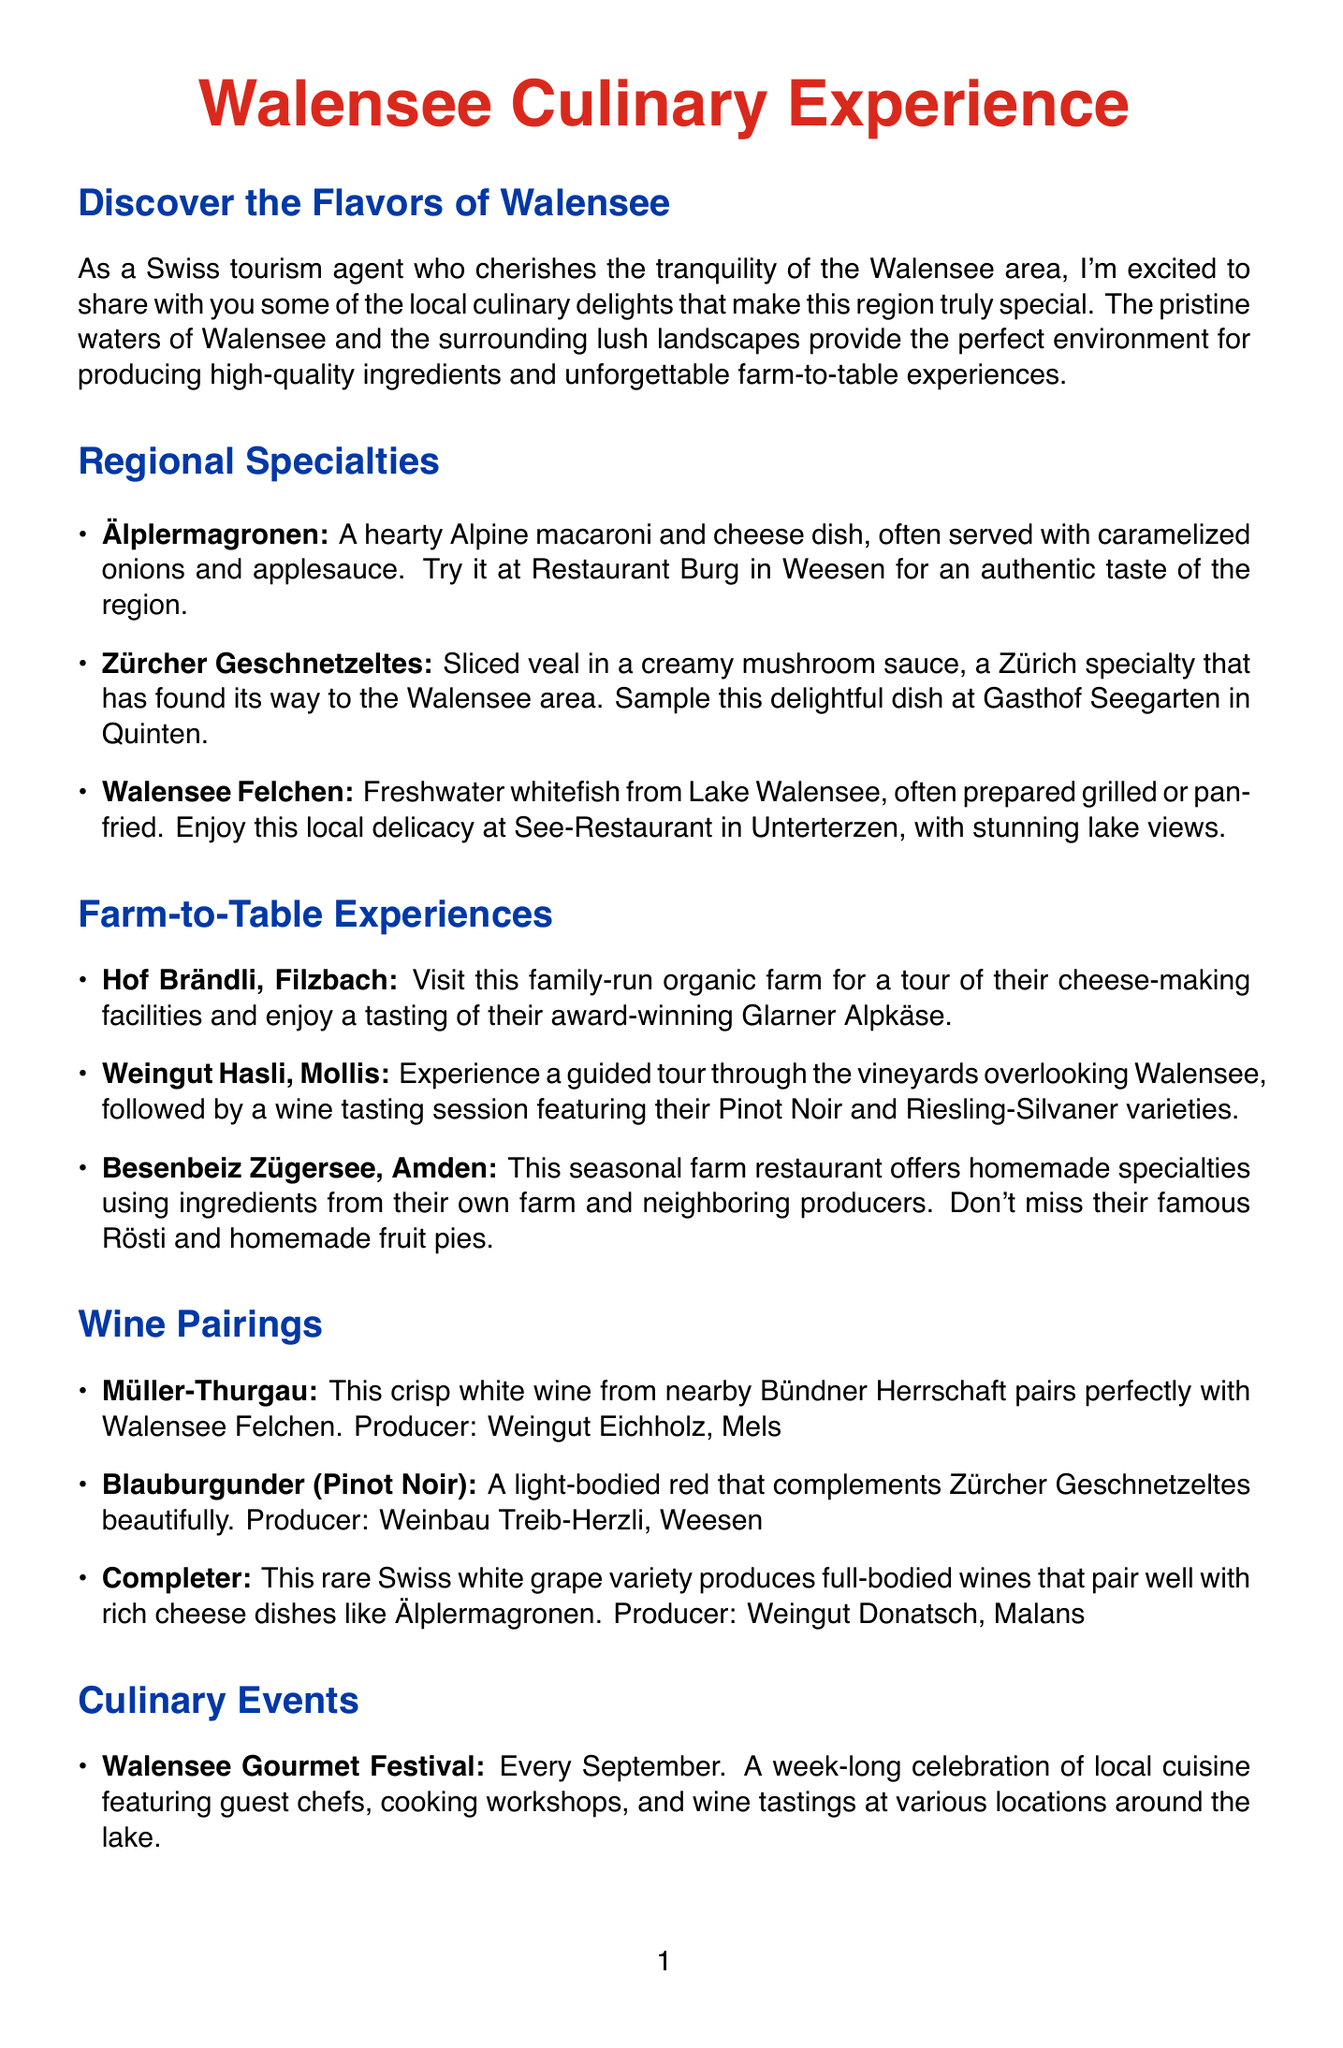What is the first culinary specialty mentioned? The first culinary specialty listed in the document is Älplermagronen.
Answer: Älplermagronen Where is Hof Brändli located? Hof Brändli is located in Filzbach.
Answer: Filzbach Which wine pairs perfectly with Walensee Felchen? The wine that pairs perfectly with Walensee Felchen is Müller-Thurgau.
Answer: Müller-Thurgau What month does the Walensee Gourmet Festival occur? The Walensee Gourmet Festival takes place every September.
Answer: September Which dish complements Zürcher Geschnetzeltes? The dish that complements Zürcher Geschnetzeltes is Blauburgunder (Pinot Noir).
Answer: Blauburgunder (Pinot Noir) What type of cheese is offered at Hof Brändli? Hof Brändli offers Glarner Alpkäse.
Answer: Glarner Alpkäse During which weekend is the Amden Alpkäse Market held? The Amden Alpkäse Market is held on the first weekend of October.
Answer: First weekend of October What is a seasonal specialty at Besenbeiz Zügersee? A seasonal specialty at Besenbeiz Zügersee is Rösti.
Answer: Rösti 